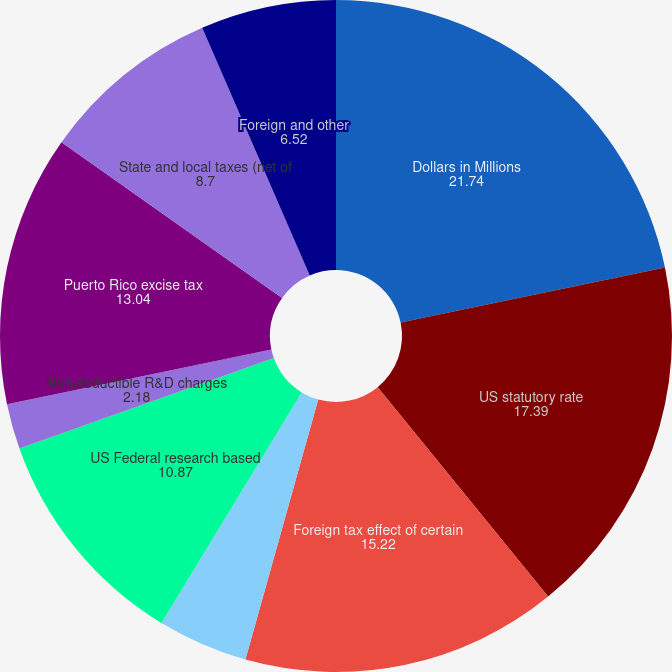Convert chart to OTSL. <chart><loc_0><loc_0><loc_500><loc_500><pie_chart><fcel>Dollars in Millions<fcel>US statutory rate<fcel>Foreign tax effect of certain<fcel>US Federal state and foreign<fcel>US Federal research based<fcel>US Branded Prescription Drug<fcel>Non-deductible R&D charges<fcel>Puerto Rico excise tax<fcel>State and local taxes (net of<fcel>Foreign and other<nl><fcel>21.74%<fcel>17.39%<fcel>15.22%<fcel>4.35%<fcel>10.87%<fcel>0.0%<fcel>2.18%<fcel>13.04%<fcel>8.7%<fcel>6.52%<nl></chart> 